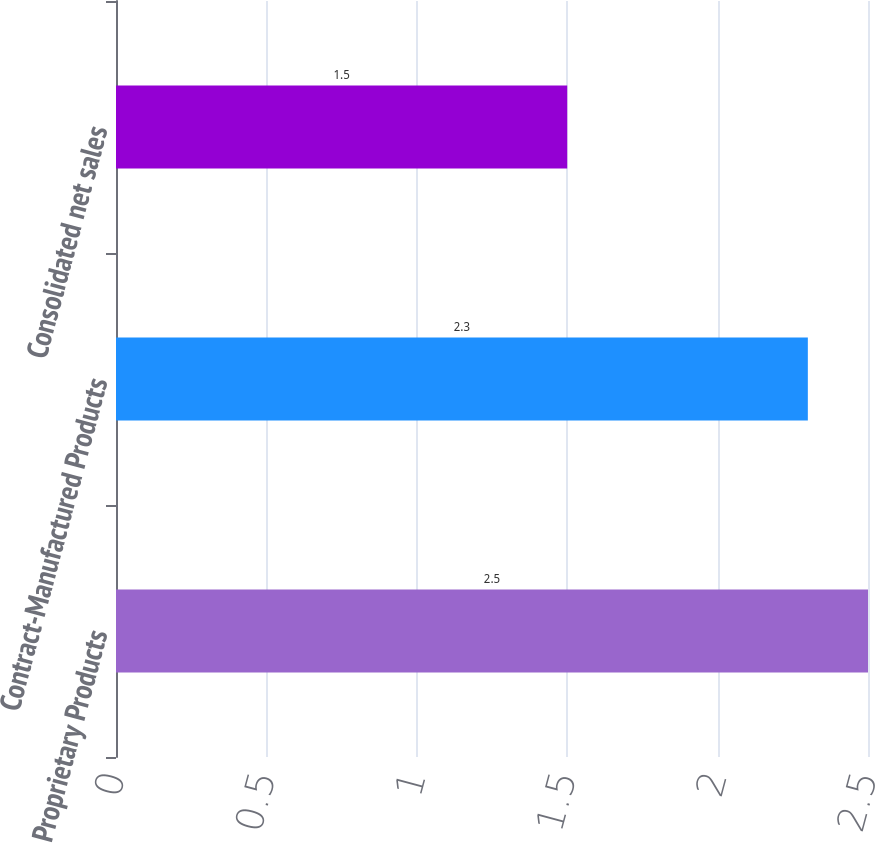Convert chart. <chart><loc_0><loc_0><loc_500><loc_500><bar_chart><fcel>Proprietary Products<fcel>Contract-Manufactured Products<fcel>Consolidated net sales<nl><fcel>2.5<fcel>2.3<fcel>1.5<nl></chart> 